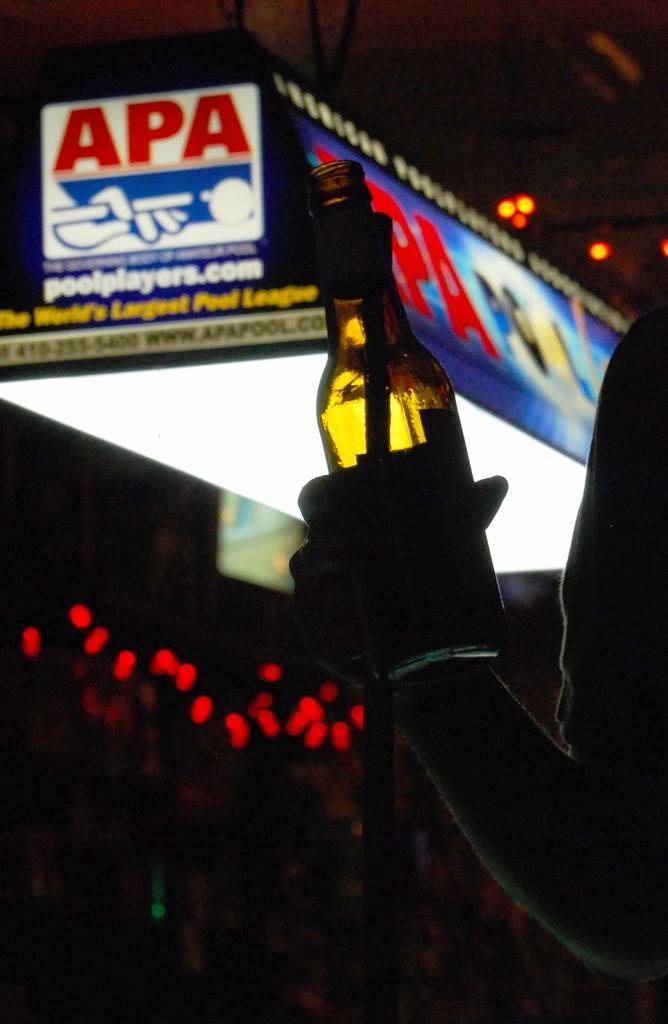<image>
Describe the image concisely. A person holds a bottle near a light with APA written on it. 